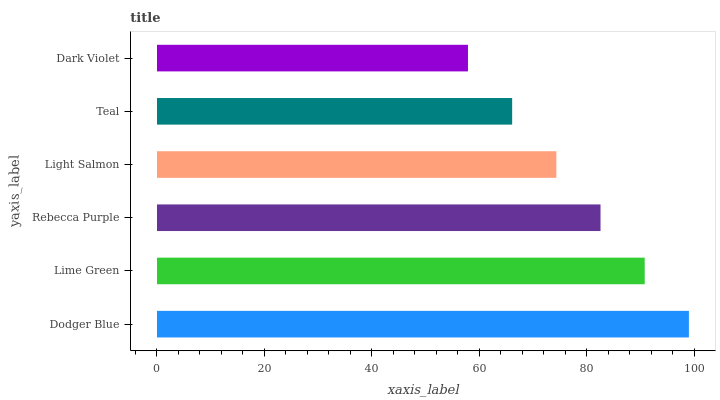Is Dark Violet the minimum?
Answer yes or no. Yes. Is Dodger Blue the maximum?
Answer yes or no. Yes. Is Lime Green the minimum?
Answer yes or no. No. Is Lime Green the maximum?
Answer yes or no. No. Is Dodger Blue greater than Lime Green?
Answer yes or no. Yes. Is Lime Green less than Dodger Blue?
Answer yes or no. Yes. Is Lime Green greater than Dodger Blue?
Answer yes or no. No. Is Dodger Blue less than Lime Green?
Answer yes or no. No. Is Rebecca Purple the high median?
Answer yes or no. Yes. Is Light Salmon the low median?
Answer yes or no. Yes. Is Light Salmon the high median?
Answer yes or no. No. Is Lime Green the low median?
Answer yes or no. No. 